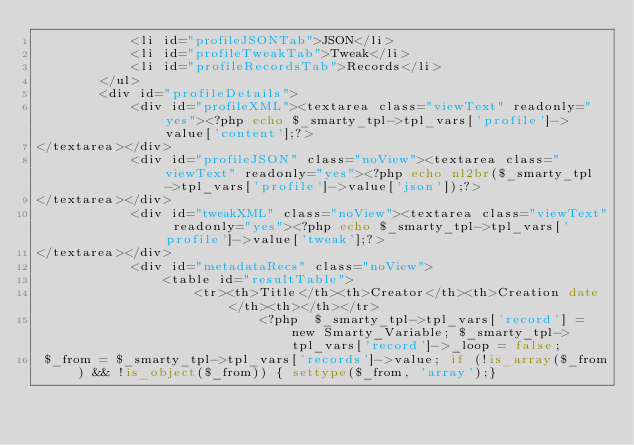<code> <loc_0><loc_0><loc_500><loc_500><_PHP_>            <li id="profileJSONTab">JSON</li>
            <li id="profileTweakTab">Tweak</li>
            <li id="profileRecordsTab">Records</li>
        </ul>
        <div id="profileDetails">
            <div id="profileXML"><textarea class="viewText" readonly="yes"><?php echo $_smarty_tpl->tpl_vars['profile']->value['content'];?>
</textarea></div>
            <div id="profileJSON" class="noView"><textarea class="viewText" readonly="yes"><?php echo nl2br($_smarty_tpl->tpl_vars['profile']->value['json']);?>
</textarea></div>
            <div id="tweakXML" class="noView"><textarea class="viewText" readonly="yes"><?php echo $_smarty_tpl->tpl_vars['profile']->value['tweak'];?>
</textarea></div>
            <div id="metadataRecs" class="noView">
                <table id="resultTable">
                    <tr><th>Title</th><th>Creator</th><th>Creation date</th><th></th></tr>
                            <?php  $_smarty_tpl->tpl_vars['record'] = new Smarty_Variable; $_smarty_tpl->tpl_vars['record']->_loop = false;
 $_from = $_smarty_tpl->tpl_vars['records']->value; if (!is_array($_from) && !is_object($_from)) { settype($_from, 'array');}</code> 